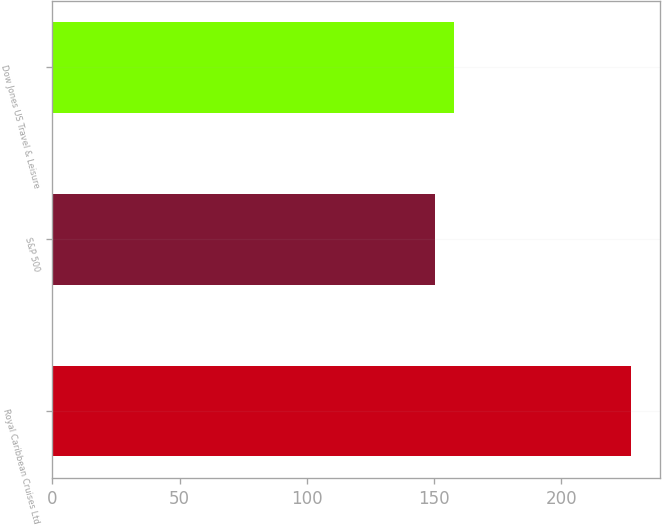<chart> <loc_0><loc_0><loc_500><loc_500><bar_chart><fcel>Royal Caribbean Cruises Ltd<fcel>S&P 500<fcel>Dow Jones US Travel & Leisure<nl><fcel>227.46<fcel>150.33<fcel>158.04<nl></chart> 